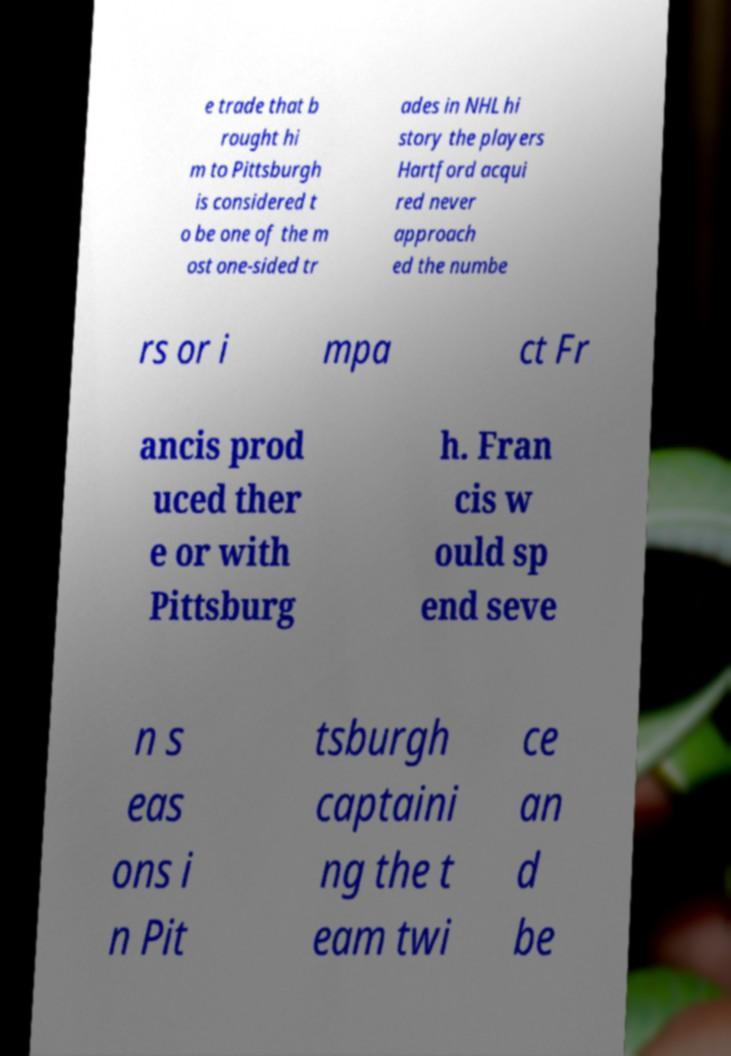What messages or text are displayed in this image? I need them in a readable, typed format. e trade that b rought hi m to Pittsburgh is considered t o be one of the m ost one-sided tr ades in NHL hi story the players Hartford acqui red never approach ed the numbe rs or i mpa ct Fr ancis prod uced ther e or with Pittsburg h. Fran cis w ould sp end seve n s eas ons i n Pit tsburgh captaini ng the t eam twi ce an d be 